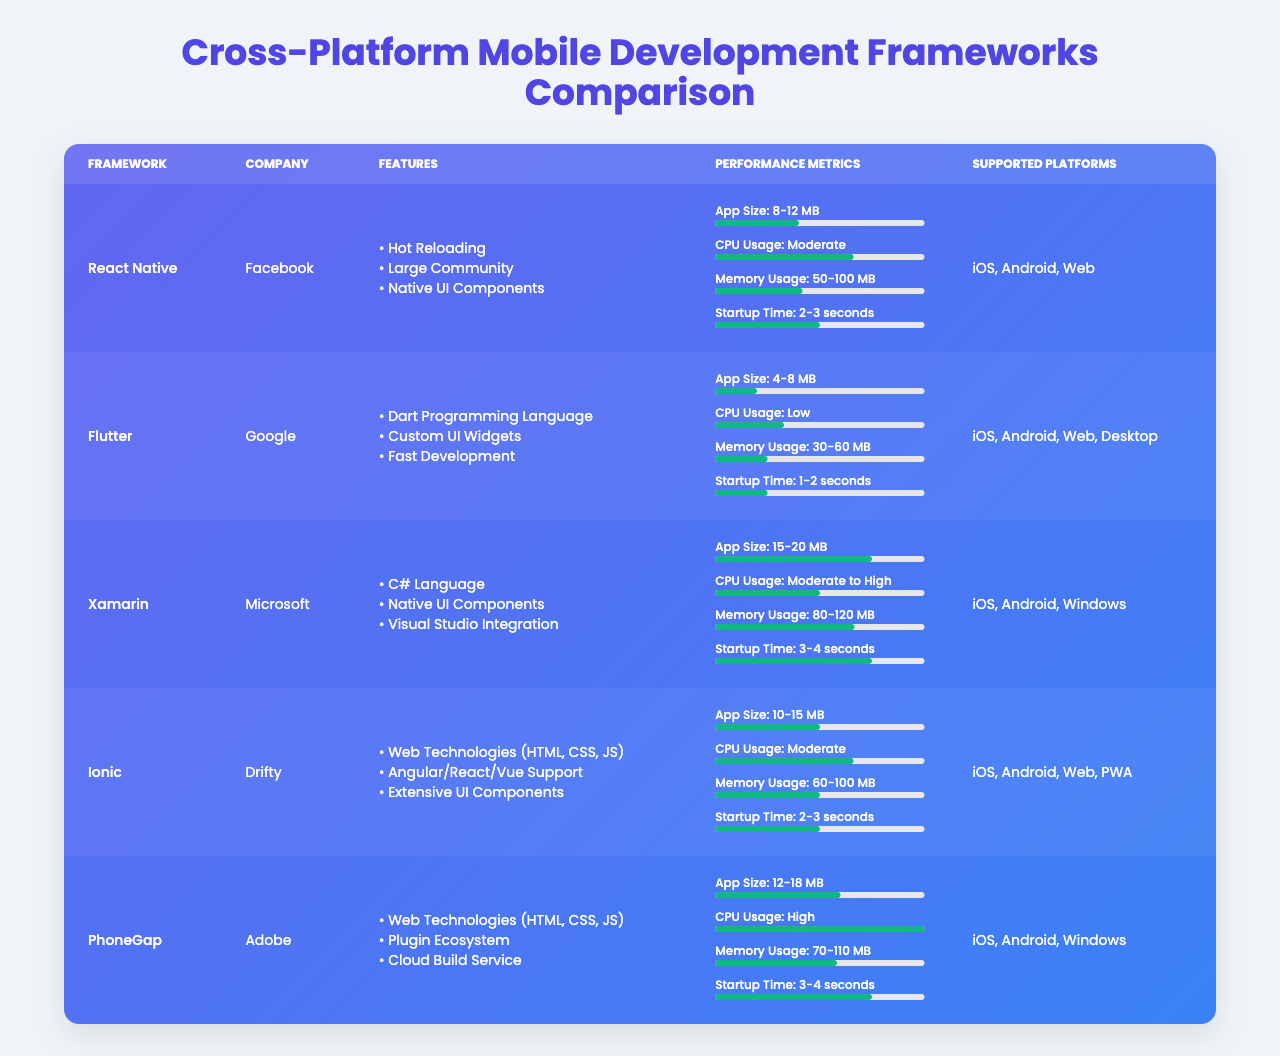What is the app size range for Flutter? According to the table, Flutter has an app size range of 4-8 MB.
Answer: 4-8 MB Which framework has the lowest memory usage? The table states that Flutter has the lowest memory usage, ranging from 30-60 MB.
Answer: Flutter Is React Native supported on the desktop platform? The table indicates that React Native supports iOS, Android, and Web, but not Desktop.
Answer: No What is the average startup time for Xamarin and PhoneGap? From the table, Xamarin has a startup time of 3-4 seconds, and PhoneGap also has a startup time of 3-4 seconds. The average is (3.5 + 3.5)/2 = 3.5 seconds.
Answer: 3.5 seconds Which framework has the highest CPU usage? The table shows that PhoneGap has high CPU usage while others range from low to moderate, making it the one with the highest usage.
Answer: PhoneGap Are there any frameworks that support Web and iOS? The table shows that React Native, Flutter, Ionic, and PhoneGap all support both Web and iOS.
Answer: Yes What is the total app size range for all frameworks combined? The table provides app size ranges: React Native (8-12 MB), Flutter (4-8 MB), Xamarin (15-20 MB), Ionic (10-15 MB), and PhoneGap (12-18 MB). When considering each range, the total range is 4 MB (minimum of Flutter) to 20 MB (maximum of Xamarin).
Answer: 4-20 MB How many frameworks have a moderate CPU usage rating? From the table, React Native and Ionic have moderate CPU usage, totaling 2 frameworks.
Answer: 2 frameworks What is the startup time for the framework with the most features? The framework with the most features is Ionic, which has a startup time of 2-3 seconds according to the table.
Answer: 2-3 seconds Which framework does not use native components? The table indicates that Ionic and PhoneGap do not primarily use native components, relying instead on web technologies.
Answer: Ionic and PhoneGap 